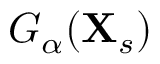<formula> <loc_0><loc_0><loc_500><loc_500>G _ { \alpha } ( X _ { s } )</formula> 